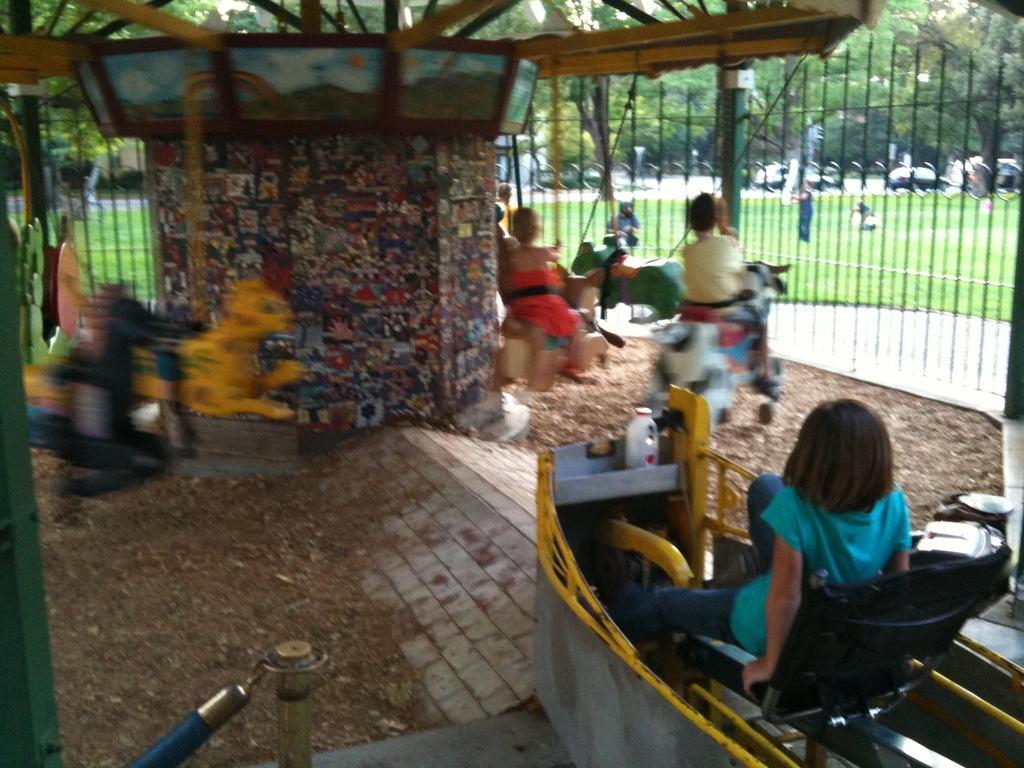How would you summarize this image in a sentence or two? In this picture there are people and we can see ride, fence and objects. In the background of the image we can see grass, persons and trees. 